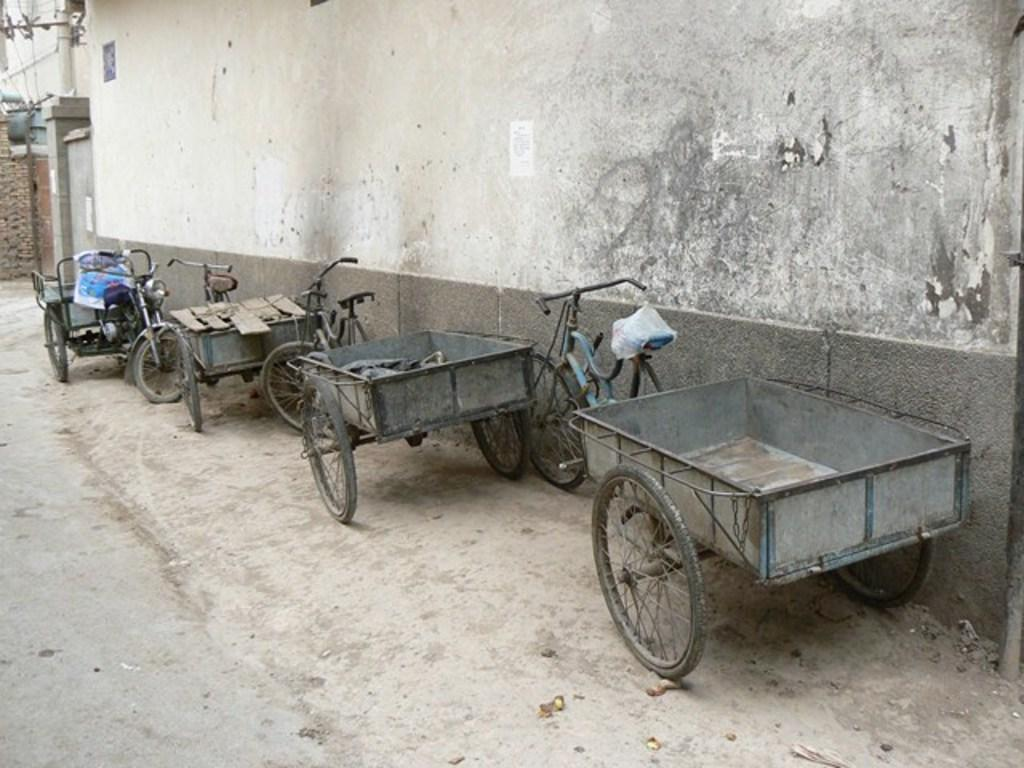What can be seen on the road in the image? There are carts on the road in the image. What type of material is used for the planks in the image? The planks in the image are made of wood. What structures are visible in the image? There are walls visible in the image. Can you describe any other objects in the image? There are some unspecified objects in the image. Is there a guitar being played on the wall in the image? There is no guitar or indication of someone playing a guitar on the wall in the image. 